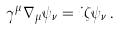Convert formula to latex. <formula><loc_0><loc_0><loc_500><loc_500>\gamma ^ { \mu } \nabla _ { \mu } \psi _ { \nu } = i \zeta \psi _ { \nu } \, .</formula> 